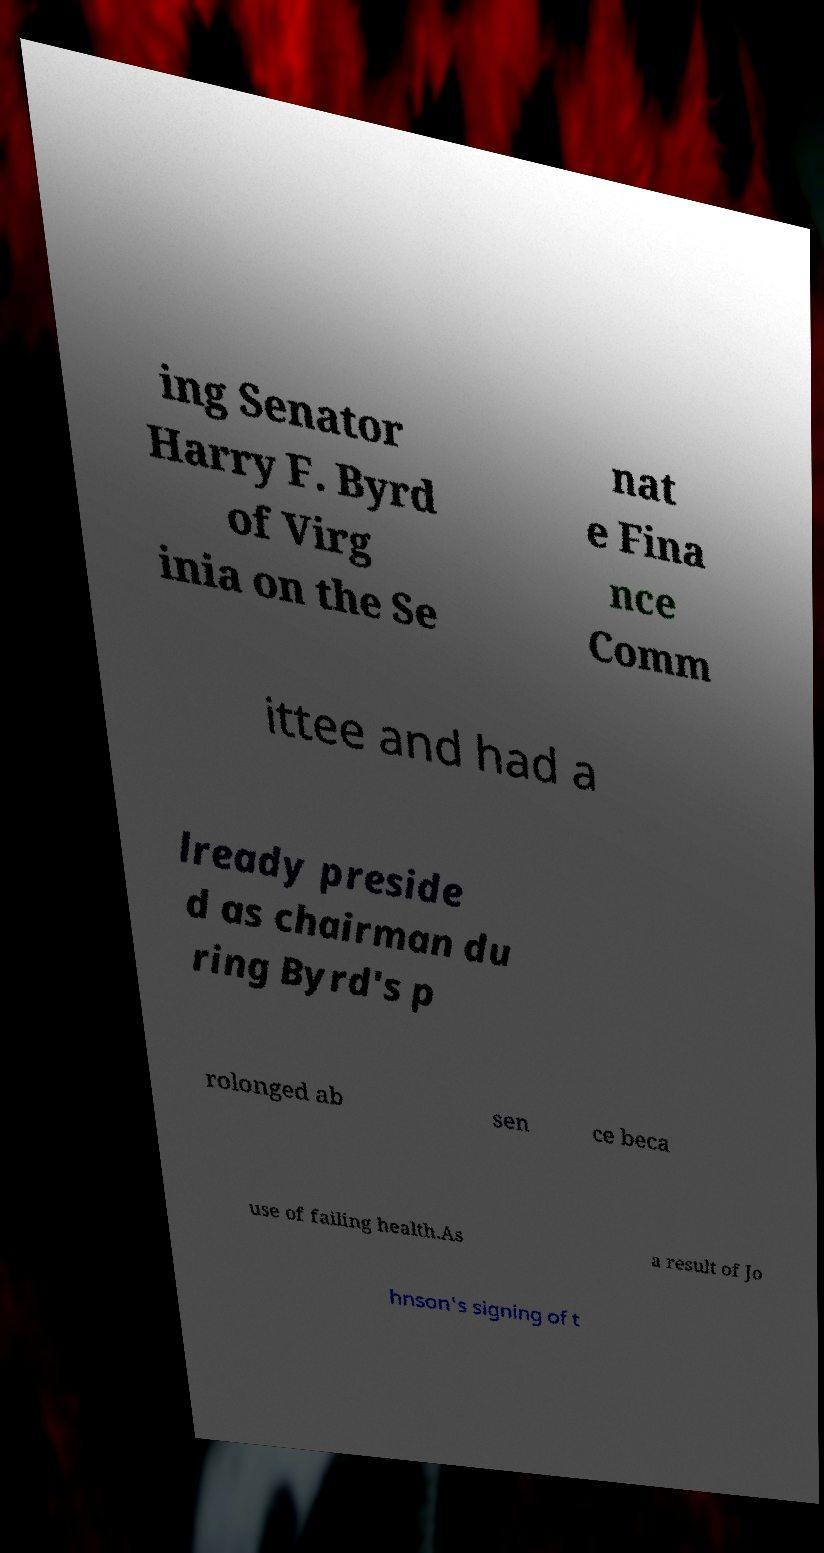Could you extract and type out the text from this image? ing Senator Harry F. Byrd of Virg inia on the Se nat e Fina nce Comm ittee and had a lready preside d as chairman du ring Byrd's p rolonged ab sen ce beca use of failing health.As a result of Jo hnson's signing of t 